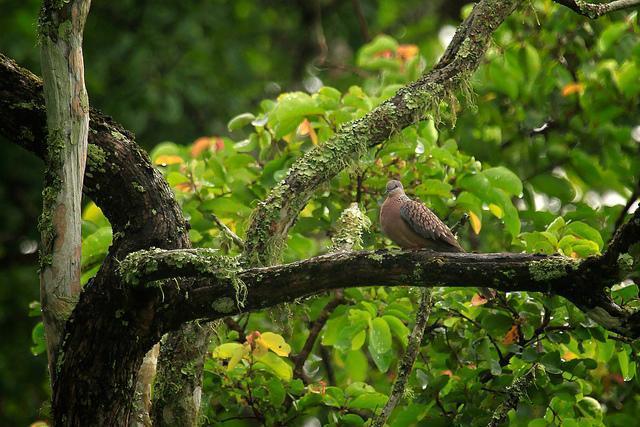How many birds on the tree?
Give a very brief answer. 1. How many birds are in the picture?
Give a very brief answer. 1. 